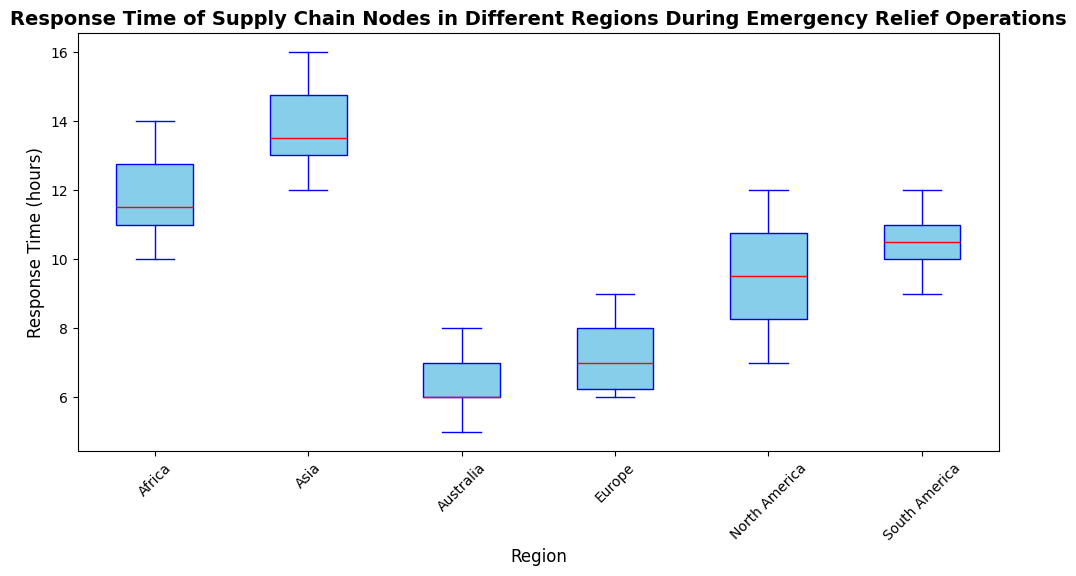What region has the median response time colored in red? The box plot uses a red line to represent the median response time for each region. By looking at the red lines, we can identify which region corresponds to its median value.
Answer: All regions Which region shows the shortest response time overall? The lowest point in the box plots represents the shortest response time for each region. By comparing these points, we can identify the region with the smallest value.
Answer: Australia Which region has the widest spread in response times? The spread in response times is represented by the distance between the lowest and highest points (whiskers) of the boxplot. Identify the region with the longest whisker length.
Answer: Asia What is the median response time for North America and how does it compare with South America? The median response time is the red line in each box. Compare the medians for North America and South America by looking at their respective red lines.
Answer: North America: 9.5, South America: 10.5 How many regions have a median response time less than 10 hours? Identify which regions' red lines (median) lie below the 10-hour mark. Count these regions.
Answer: 4 (Europe, Australia, North America, South America) What's the interquartile range (IQR) for Europe? The IQR is the range between the lower quartile (Q1) and upper quartile (Q3). On the boxplot, the bottom and top edges of the box represent Q1 and Q3. Find these values and compute the difference.
Answer: IQR = 8 - 6 = 2 (hours) Which regions have outliers and how are they depicted? Outliers are typically shown as individual points outside the whiskers. Identify the regions that have dots representing outliers.
Answer: North America, Asia, Africa, and South America Compare the distribution of response times between Europe and Asia. Which region has a more consistent response time and why? Compare the ranges (whiskers) and the size of the boxes for both Europe and Asia. A smaller range and box denote more consistency.
Answer: Europe is more consistent (smaller range and box) What is the approximate range of response times for Africa? The range is indicated by the whiskers of the boxplot, going from the lowest to the highest point. Note down these values for Africa.
Answer: Range: 10 to 14 (hours) In which region does the response time vary the most and how can you tell? The region with the most variation will have the largest difference between the minimum and maximum values (whiskers). Identify this region.
Answer: Asia 